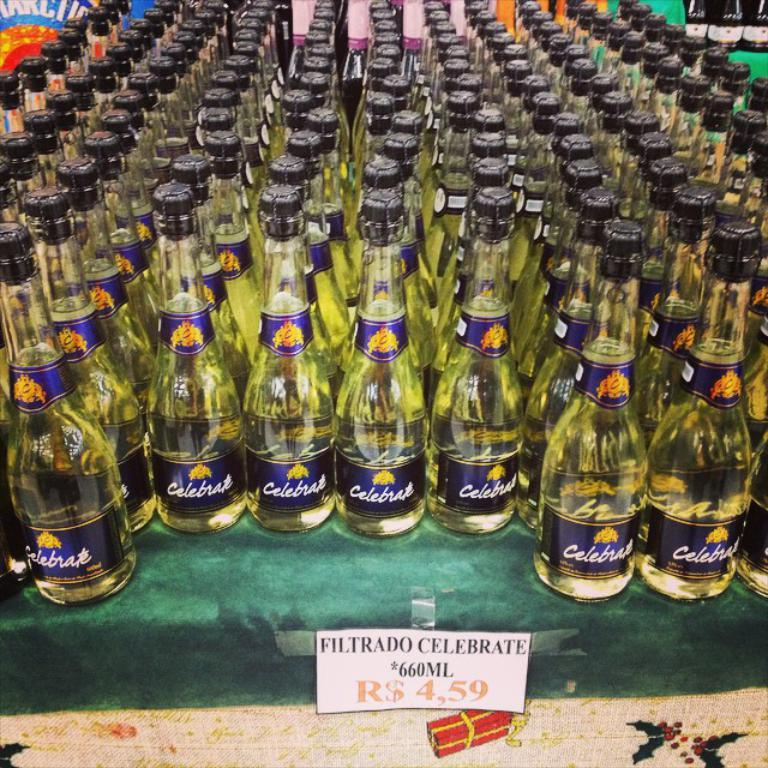<image>
Present a compact description of the photo's key features. A sign for filtrado celebrate in front of several bottles. 